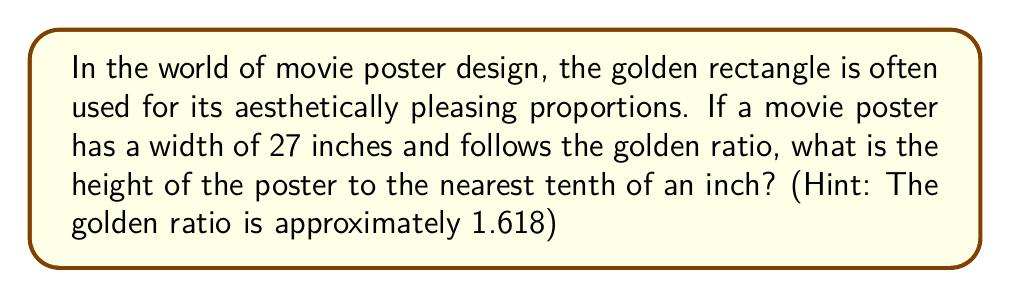Give your solution to this math problem. Let's approach this step-by-step:

1) The golden rectangle has a ratio of length to width of approximately 1.618:1.

2) In this case, we're given the width (shorter side) of 27 inches.

3) To find the height (longer side), we need to multiply the width by the golden ratio:

   $$ \text{Height} = \text{Width} \times \text{Golden Ratio} $$

4) Plugging in our values:

   $$ \text{Height} = 27 \times 1.618 $$

5) Let's calculate:

   $$ \text{Height} = 43.686 \text{ inches} $$

6) Rounding to the nearest tenth:

   $$ \text{Height} \approx 43.7 \text{ inches} $$

[asy]
size(200);
real w = 27;
real h = w * 1.618;
draw((0,0)--(w,0)--(w,h)--(0,h)--cycle);
label("27\"", (w/2,0), S);
label("43.7\"", (w,h/2), E);
[/asy]
Answer: 43.7 inches 